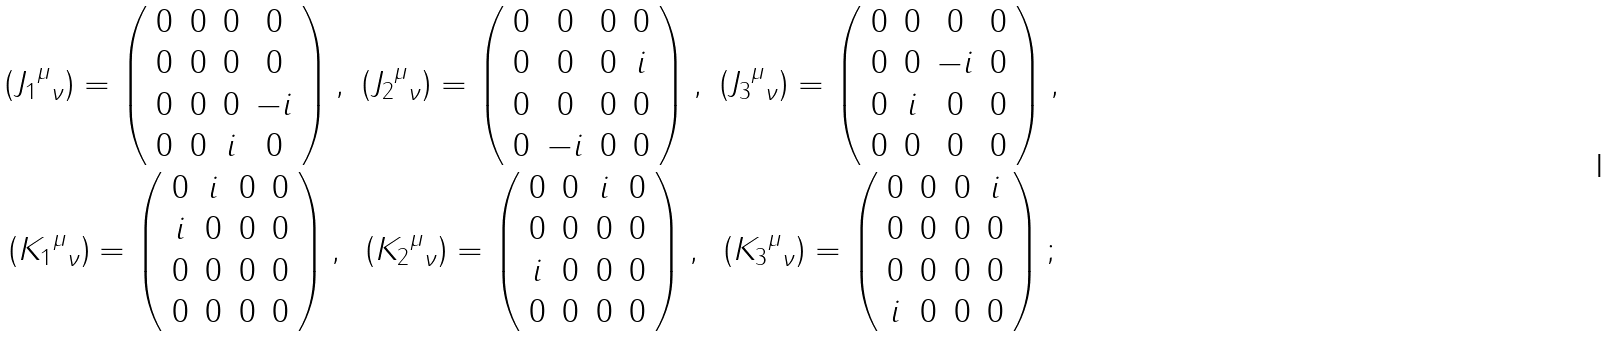Convert formula to latex. <formula><loc_0><loc_0><loc_500><loc_500>\begin{array} { c c c } \left ( { { J _ { 1 } } ^ { \mu } } _ { \nu } \right ) = \left ( \begin{array} { c c c c } 0 & 0 & 0 & 0 \\ 0 & 0 & 0 & 0 \\ 0 & 0 & 0 & - i \\ 0 & 0 & i & 0 \end{array} \right ) , & \left ( { { J _ { 2 } } ^ { \mu } } _ { \nu } \right ) = \left ( \begin{array} { c c c c } 0 & 0 & 0 & 0 \\ 0 & 0 & 0 & i \\ 0 & 0 & 0 & 0 \\ 0 & - i & 0 & 0 \end{array} \right ) , & \left ( { { J _ { 3 } } ^ { \mu } } _ { \nu } \right ) = \left ( \begin{array} { c c c c } 0 & 0 & 0 & 0 \\ 0 & 0 & - i & 0 \\ 0 & i & 0 & 0 \\ 0 & 0 & 0 & 0 \end{array} \right ) , \\ \left ( { { K _ { 1 } } ^ { \mu } } _ { \nu } \right ) = \left ( \begin{array} { c c c c } 0 & i & 0 & 0 \\ i & 0 & 0 & 0 \\ 0 & 0 & 0 & 0 \\ 0 & 0 & 0 & 0 \end{array} \right ) , & \left ( { { K _ { 2 } } ^ { \mu } } _ { \nu } \right ) = \left ( \begin{array} { c c c c } 0 & 0 & i & 0 \\ 0 & 0 & 0 & 0 \\ i & 0 & 0 & 0 \\ 0 & 0 & 0 & 0 \end{array} \right ) , & \left ( { { K _ { 3 } } ^ { \mu } } _ { \nu } \right ) = \left ( \begin{array} { c c c c } 0 & 0 & 0 & i \\ 0 & 0 & 0 & 0 \\ 0 & 0 & 0 & 0 \\ i & 0 & 0 & 0 \end{array} \right ) ; \end{array}</formula> 